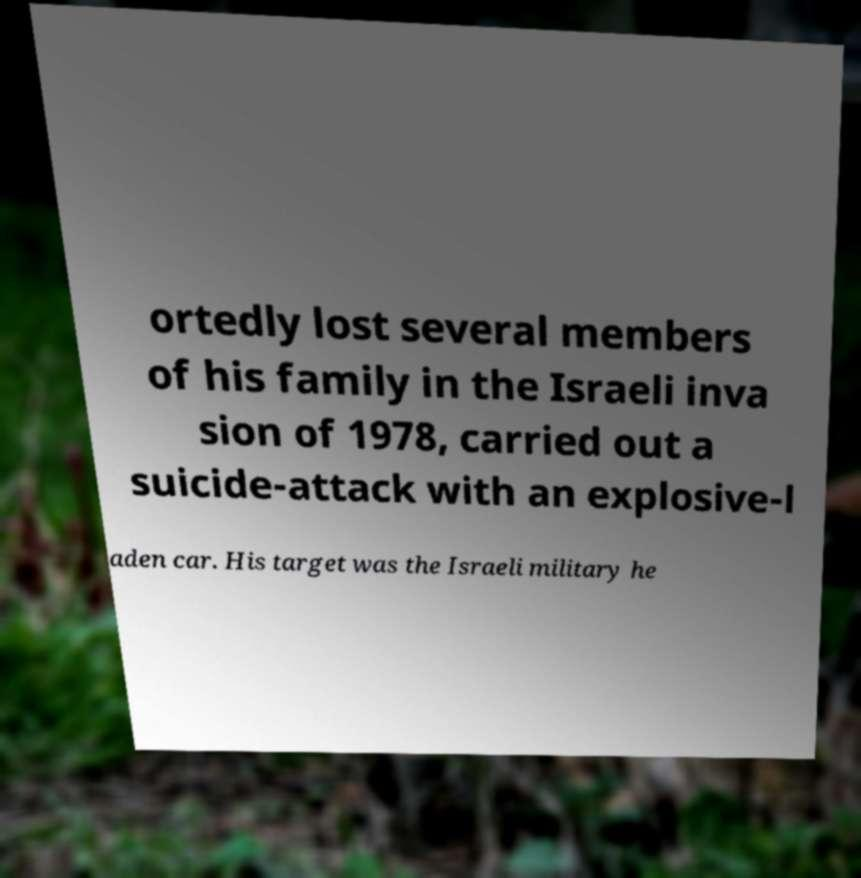Could you assist in decoding the text presented in this image and type it out clearly? ortedly lost several members of his family in the Israeli inva sion of 1978, carried out a suicide-attack with an explosive-l aden car. His target was the Israeli military he 